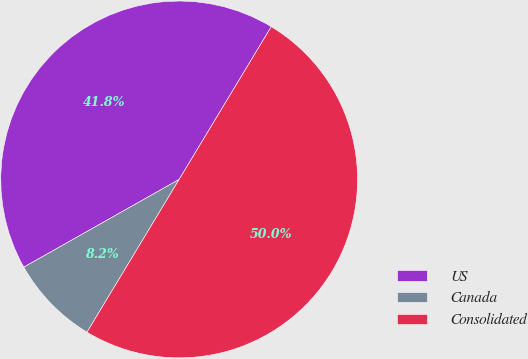<chart> <loc_0><loc_0><loc_500><loc_500><pie_chart><fcel>US<fcel>Canada<fcel>Consolidated<nl><fcel>41.82%<fcel>8.18%<fcel>50.0%<nl></chart> 